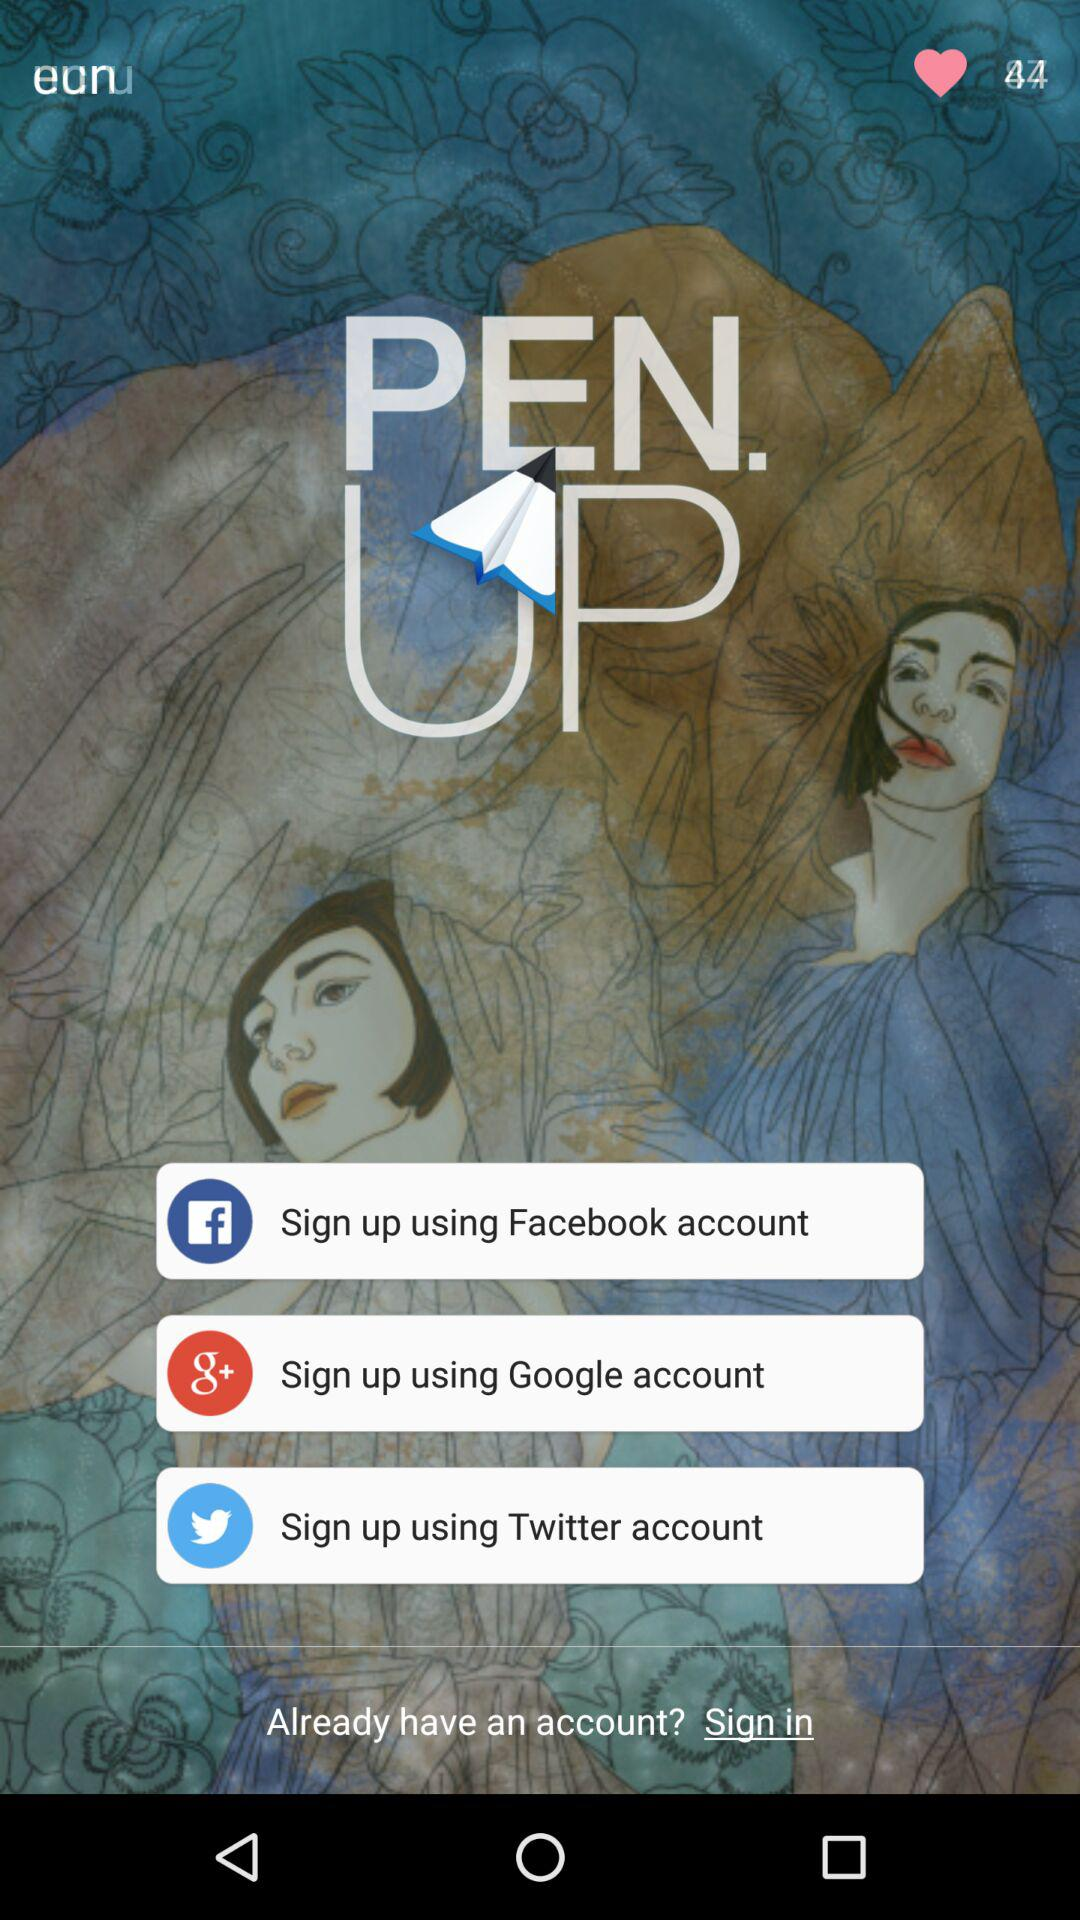What is the name of the application? The name of the application is "PEN.UP". 